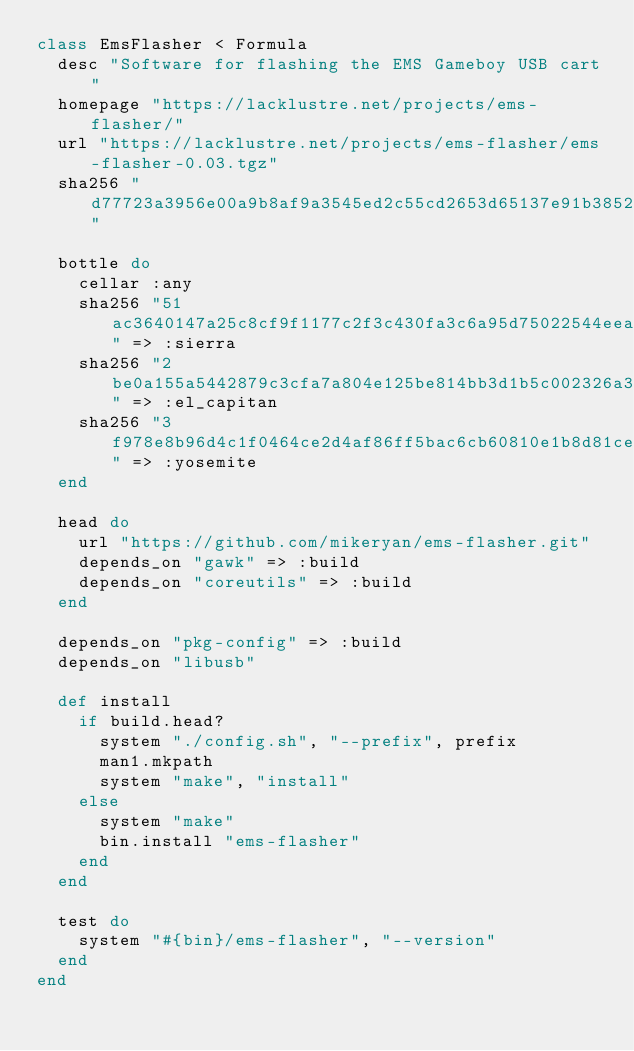Convert code to text. <code><loc_0><loc_0><loc_500><loc_500><_Ruby_>class EmsFlasher < Formula
  desc "Software for flashing the EMS Gameboy USB cart"
  homepage "https://lacklustre.net/projects/ems-flasher/"
  url "https://lacklustre.net/projects/ems-flasher/ems-flasher-0.03.tgz"
  sha256 "d77723a3956e00a9b8af9a3545ed2c55cd2653d65137e91b38523f7805316786"

  bottle do
    cellar :any
    sha256 "51ac3640147a25c8cf9f1177c2f3c430fa3c6a95d75022544eea825b14934593" => :sierra
    sha256 "2be0a155a5442879c3cfa7a804e125be814bb3d1b5c002326a33e0b84ce6024b" => :el_capitan
    sha256 "3f978e8b96d4c1f0464ce2d4af86ff5bac6cb60810e1b8d81ce4fe55bb2abb63" => :yosemite
  end

  head do
    url "https://github.com/mikeryan/ems-flasher.git"
    depends_on "gawk" => :build
    depends_on "coreutils" => :build
  end

  depends_on "pkg-config" => :build
  depends_on "libusb"

  def install
    if build.head?
      system "./config.sh", "--prefix", prefix
      man1.mkpath
      system "make", "install"
    else
      system "make"
      bin.install "ems-flasher"
    end
  end

  test do
    system "#{bin}/ems-flasher", "--version"
  end
end
</code> 